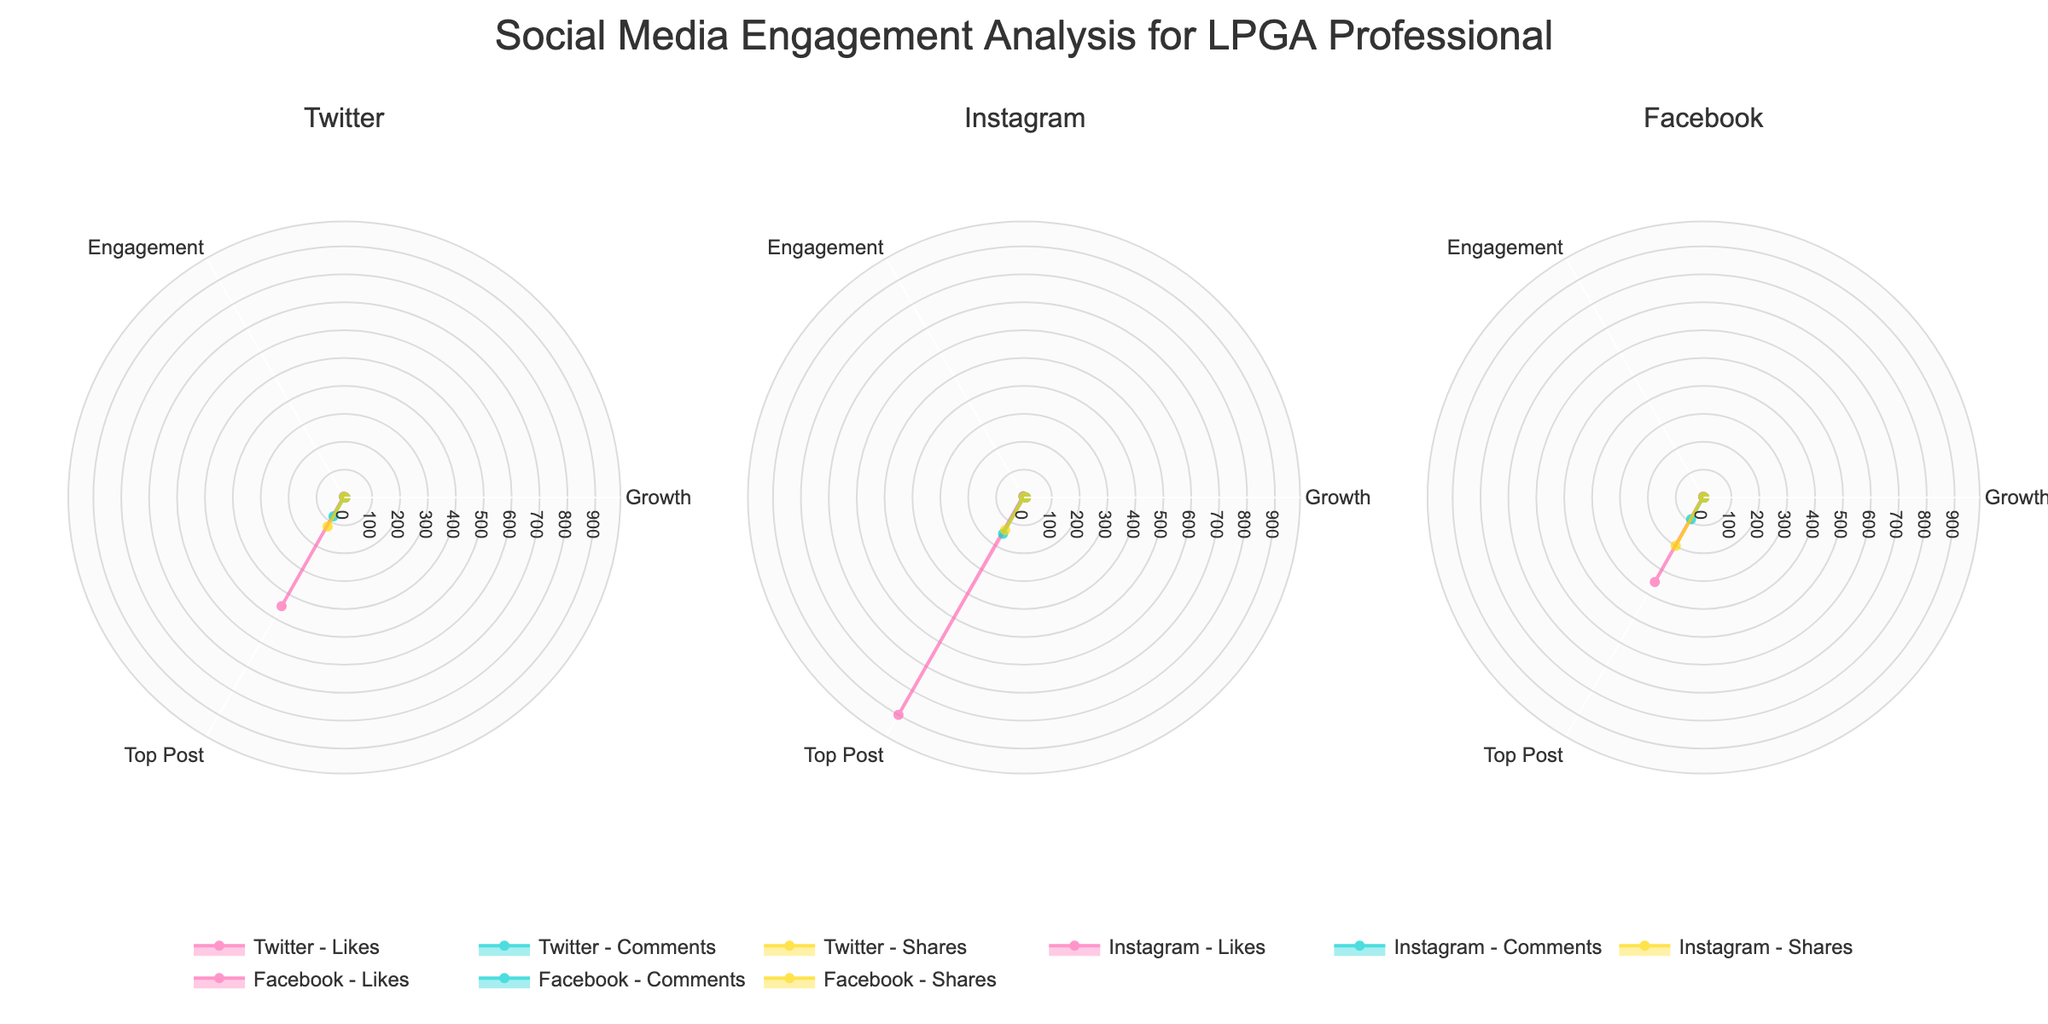What are the titles of the subplots? The subplot titles are given at the top of each radar chart, which are the names of the platforms being analyzed. Each subplot corresponds to a different social media platform.
Answer: Twitter, Instagram, Facebook What color is used for representing 'Likes' in the radar charts? The 'Likes' data is represented by the color pink, which helps distinguish it from other engagement types across all subplots.
Answer: Pink Which platform has the highest Quarterly Followers Growth? Instagram has the highest Quarterly Followers Growth. This can be observed from the radial axis values for the 'Growth' dimension, where Instagram reaches 7.2.
Answer: Instagram Which engagement type on Facebook has the highest Top Post Engagement? The 'Shares' category on Facebook has the highest Top Post Engagement. This is indicated by the radial axis value for 'Top Post' in the Facebook subplot, where Shares reach 200.
Answer: Shares Which platform shows a higher overall engagement rate for comments, Twitter or Facebook? By comparing the radial axis values for the 'Engagement' dimension in the subplots for Twitter and Facebook, Twitter's engagement rate for comments is 1.7, whereas Facebook's engagement rate for comments is 2.2. Thus, Facebook has a higher engagement rate for comments.
Answer: Facebook Which social media platform has the least engagement based on top post engagement for all types combined? By comparing the values for 'Top Post' across all engagement types (Likes, Comments, Shares) in each platform's subplot, Twitter consistently has lower values compared to both Instagram and Facebook.
Answer: Twitter What's the sum of the engagement rates across all types of engagement for Twitter? The engagement rates for Twitter are 4.2 (Likes), 1.7 (Comments), and 2.1 (Shares). Adding these together: 4.2 + 1.7 + 2.1 = 8.0.
Answer: 8.0 Between Instagram and Facebook, which platform has a higher quarterly engagement rate for Likes, and by how much? Instagram's quarterly engagement rate for Likes is 5.4, while Facebook's is 3.8. The difference is 5.4 - 3.8 = 1.6.
Answer: Instagram by 1.6 Which platform has the most evenly distributed values across all engagement types in terms of Quarterly Followers Growth? Twitter exhibits the same value of Quarterly Followers Growth (3.5) for all engagement types (Likes, Comments, Shares), indicating even distribution.
Answer: Twitter 